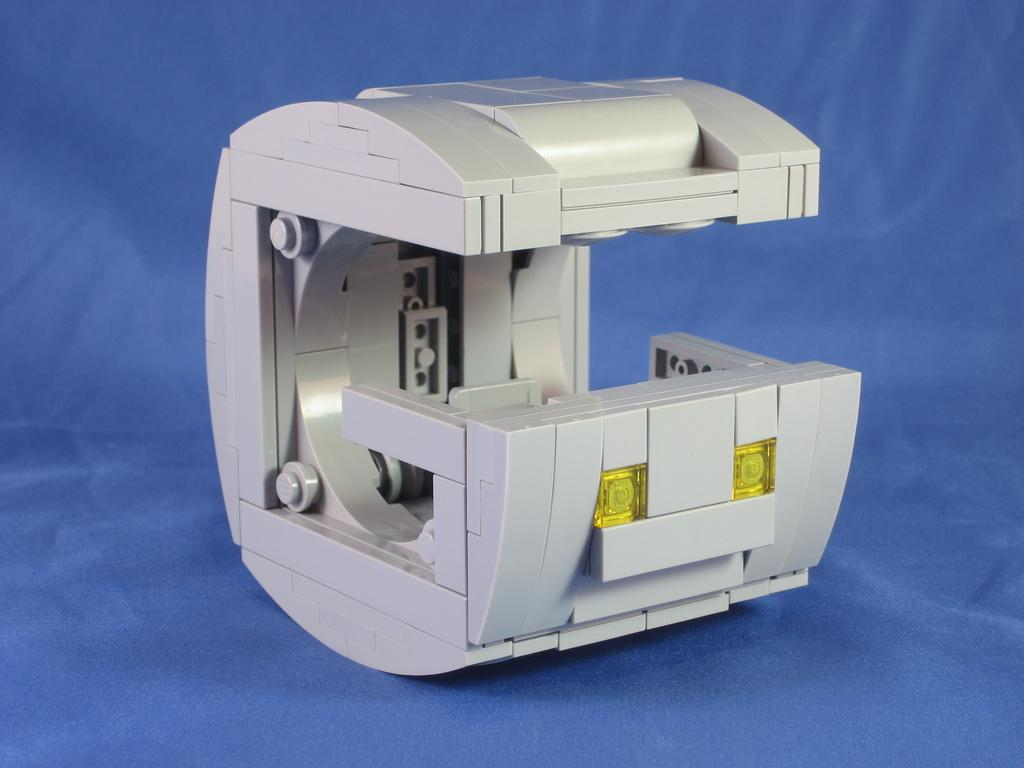What object can be seen in the image? There is an instrument in the image. What is the color of the instrument? The instrument is white in color. What else can be seen in the image besides the instrument? There is a blue colored surface in the image. How many bells are hanging from the instrument in the image? There are no bells present in the image; it features a white instrument and a blue surface. What type of sign is displayed on the instrument in the image? There is no sign displayed on the instrument in the image. 